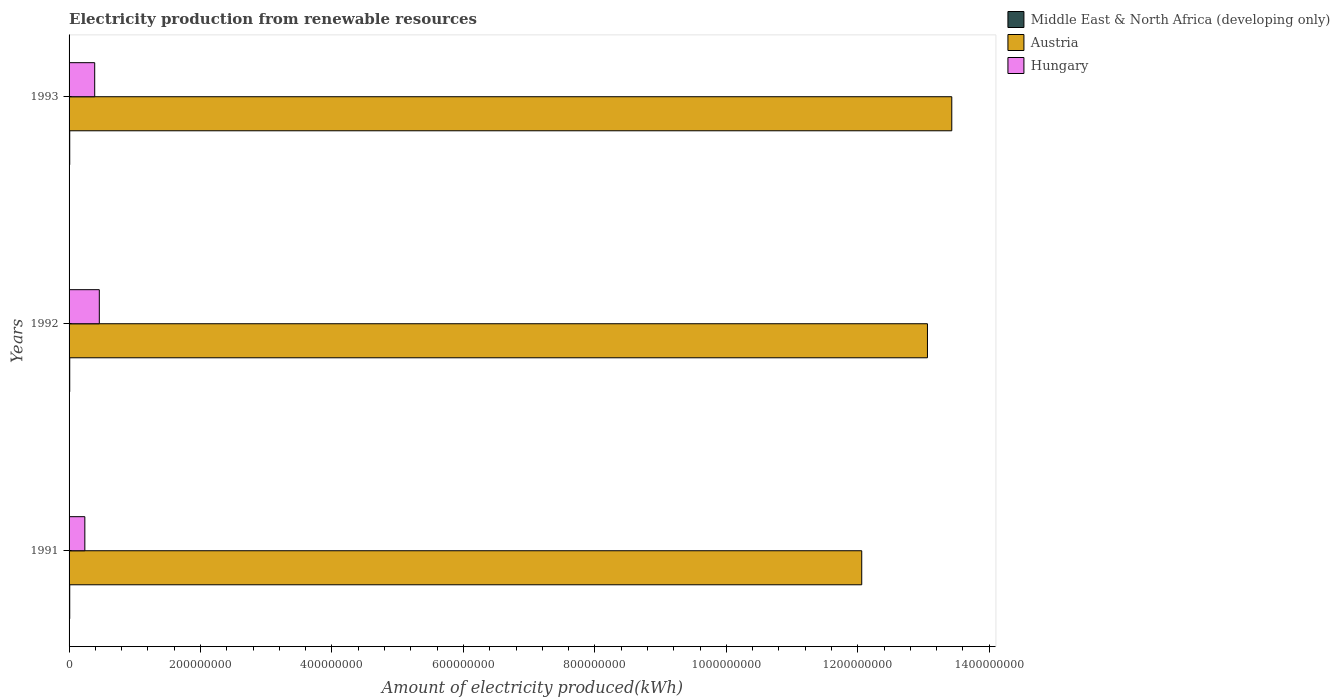How many groups of bars are there?
Provide a short and direct response. 3. How many bars are there on the 2nd tick from the bottom?
Keep it short and to the point. 3. What is the amount of electricity produced in Austria in 1993?
Your answer should be very brief. 1.34e+09. Across all years, what is the maximum amount of electricity produced in Middle East & North Africa (developing only)?
Your answer should be very brief. 1.00e+06. Across all years, what is the minimum amount of electricity produced in Hungary?
Make the answer very short. 2.40e+07. In which year was the amount of electricity produced in Hungary maximum?
Make the answer very short. 1992. What is the total amount of electricity produced in Hungary in the graph?
Offer a terse response. 1.09e+08. What is the difference between the amount of electricity produced in Hungary in 1992 and that in 1993?
Ensure brevity in your answer.  7.00e+06. What is the difference between the amount of electricity produced in Austria in 1993 and the amount of electricity produced in Hungary in 1992?
Provide a succinct answer. 1.30e+09. What is the average amount of electricity produced in Hungary per year?
Your answer should be very brief. 3.63e+07. In the year 1993, what is the difference between the amount of electricity produced in Austria and amount of electricity produced in Middle East & North Africa (developing only)?
Your answer should be compact. 1.34e+09. Is the amount of electricity produced in Middle East & North Africa (developing only) in 1992 less than that in 1993?
Offer a very short reply. No. Is the difference between the amount of electricity produced in Austria in 1991 and 1993 greater than the difference between the amount of electricity produced in Middle East & North Africa (developing only) in 1991 and 1993?
Your answer should be compact. No. What is the difference between the highest and the second highest amount of electricity produced in Austria?
Make the answer very short. 3.70e+07. What is the difference between the highest and the lowest amount of electricity produced in Hungary?
Your answer should be very brief. 2.20e+07. In how many years, is the amount of electricity produced in Middle East & North Africa (developing only) greater than the average amount of electricity produced in Middle East & North Africa (developing only) taken over all years?
Offer a terse response. 0. What does the 3rd bar from the top in 1993 represents?
Offer a terse response. Middle East & North Africa (developing only). What does the 2nd bar from the bottom in 1991 represents?
Make the answer very short. Austria. How many bars are there?
Offer a very short reply. 9. Are all the bars in the graph horizontal?
Your answer should be compact. Yes. How many years are there in the graph?
Keep it short and to the point. 3. Does the graph contain grids?
Keep it short and to the point. No. Where does the legend appear in the graph?
Ensure brevity in your answer.  Top right. How many legend labels are there?
Give a very brief answer. 3. What is the title of the graph?
Keep it short and to the point. Electricity production from renewable resources. Does "Eritrea" appear as one of the legend labels in the graph?
Provide a short and direct response. No. What is the label or title of the X-axis?
Your response must be concise. Amount of electricity produced(kWh). What is the Amount of electricity produced(kWh) in Austria in 1991?
Offer a terse response. 1.21e+09. What is the Amount of electricity produced(kWh) in Hungary in 1991?
Provide a short and direct response. 2.40e+07. What is the Amount of electricity produced(kWh) in Austria in 1992?
Provide a short and direct response. 1.31e+09. What is the Amount of electricity produced(kWh) of Hungary in 1992?
Give a very brief answer. 4.60e+07. What is the Amount of electricity produced(kWh) of Austria in 1993?
Provide a short and direct response. 1.34e+09. What is the Amount of electricity produced(kWh) of Hungary in 1993?
Make the answer very short. 3.90e+07. Across all years, what is the maximum Amount of electricity produced(kWh) of Middle East & North Africa (developing only)?
Your response must be concise. 1.00e+06. Across all years, what is the maximum Amount of electricity produced(kWh) of Austria?
Provide a succinct answer. 1.34e+09. Across all years, what is the maximum Amount of electricity produced(kWh) in Hungary?
Offer a very short reply. 4.60e+07. Across all years, what is the minimum Amount of electricity produced(kWh) of Middle East & North Africa (developing only)?
Offer a terse response. 1.00e+06. Across all years, what is the minimum Amount of electricity produced(kWh) in Austria?
Ensure brevity in your answer.  1.21e+09. Across all years, what is the minimum Amount of electricity produced(kWh) of Hungary?
Your answer should be compact. 2.40e+07. What is the total Amount of electricity produced(kWh) of Austria in the graph?
Offer a terse response. 3.86e+09. What is the total Amount of electricity produced(kWh) in Hungary in the graph?
Make the answer very short. 1.09e+08. What is the difference between the Amount of electricity produced(kWh) of Austria in 1991 and that in 1992?
Give a very brief answer. -1.00e+08. What is the difference between the Amount of electricity produced(kWh) in Hungary in 1991 and that in 1992?
Keep it short and to the point. -2.20e+07. What is the difference between the Amount of electricity produced(kWh) of Austria in 1991 and that in 1993?
Provide a short and direct response. -1.37e+08. What is the difference between the Amount of electricity produced(kWh) in Hungary in 1991 and that in 1993?
Ensure brevity in your answer.  -1.50e+07. What is the difference between the Amount of electricity produced(kWh) in Middle East & North Africa (developing only) in 1992 and that in 1993?
Your answer should be compact. 0. What is the difference between the Amount of electricity produced(kWh) of Austria in 1992 and that in 1993?
Keep it short and to the point. -3.70e+07. What is the difference between the Amount of electricity produced(kWh) of Middle East & North Africa (developing only) in 1991 and the Amount of electricity produced(kWh) of Austria in 1992?
Ensure brevity in your answer.  -1.30e+09. What is the difference between the Amount of electricity produced(kWh) of Middle East & North Africa (developing only) in 1991 and the Amount of electricity produced(kWh) of Hungary in 1992?
Make the answer very short. -4.50e+07. What is the difference between the Amount of electricity produced(kWh) of Austria in 1991 and the Amount of electricity produced(kWh) of Hungary in 1992?
Make the answer very short. 1.16e+09. What is the difference between the Amount of electricity produced(kWh) in Middle East & North Africa (developing only) in 1991 and the Amount of electricity produced(kWh) in Austria in 1993?
Give a very brief answer. -1.34e+09. What is the difference between the Amount of electricity produced(kWh) in Middle East & North Africa (developing only) in 1991 and the Amount of electricity produced(kWh) in Hungary in 1993?
Provide a succinct answer. -3.80e+07. What is the difference between the Amount of electricity produced(kWh) in Austria in 1991 and the Amount of electricity produced(kWh) in Hungary in 1993?
Your answer should be compact. 1.17e+09. What is the difference between the Amount of electricity produced(kWh) of Middle East & North Africa (developing only) in 1992 and the Amount of electricity produced(kWh) of Austria in 1993?
Give a very brief answer. -1.34e+09. What is the difference between the Amount of electricity produced(kWh) in Middle East & North Africa (developing only) in 1992 and the Amount of electricity produced(kWh) in Hungary in 1993?
Your response must be concise. -3.80e+07. What is the difference between the Amount of electricity produced(kWh) of Austria in 1992 and the Amount of electricity produced(kWh) of Hungary in 1993?
Provide a short and direct response. 1.27e+09. What is the average Amount of electricity produced(kWh) of Austria per year?
Offer a very short reply. 1.28e+09. What is the average Amount of electricity produced(kWh) in Hungary per year?
Your answer should be compact. 3.63e+07. In the year 1991, what is the difference between the Amount of electricity produced(kWh) in Middle East & North Africa (developing only) and Amount of electricity produced(kWh) in Austria?
Keep it short and to the point. -1.20e+09. In the year 1991, what is the difference between the Amount of electricity produced(kWh) in Middle East & North Africa (developing only) and Amount of electricity produced(kWh) in Hungary?
Provide a succinct answer. -2.30e+07. In the year 1991, what is the difference between the Amount of electricity produced(kWh) of Austria and Amount of electricity produced(kWh) of Hungary?
Your answer should be compact. 1.18e+09. In the year 1992, what is the difference between the Amount of electricity produced(kWh) of Middle East & North Africa (developing only) and Amount of electricity produced(kWh) of Austria?
Make the answer very short. -1.30e+09. In the year 1992, what is the difference between the Amount of electricity produced(kWh) of Middle East & North Africa (developing only) and Amount of electricity produced(kWh) of Hungary?
Offer a very short reply. -4.50e+07. In the year 1992, what is the difference between the Amount of electricity produced(kWh) of Austria and Amount of electricity produced(kWh) of Hungary?
Your answer should be compact. 1.26e+09. In the year 1993, what is the difference between the Amount of electricity produced(kWh) in Middle East & North Africa (developing only) and Amount of electricity produced(kWh) in Austria?
Offer a terse response. -1.34e+09. In the year 1993, what is the difference between the Amount of electricity produced(kWh) in Middle East & North Africa (developing only) and Amount of electricity produced(kWh) in Hungary?
Your answer should be compact. -3.80e+07. In the year 1993, what is the difference between the Amount of electricity produced(kWh) of Austria and Amount of electricity produced(kWh) of Hungary?
Give a very brief answer. 1.30e+09. What is the ratio of the Amount of electricity produced(kWh) of Middle East & North Africa (developing only) in 1991 to that in 1992?
Provide a short and direct response. 1. What is the ratio of the Amount of electricity produced(kWh) of Austria in 1991 to that in 1992?
Keep it short and to the point. 0.92. What is the ratio of the Amount of electricity produced(kWh) of Hungary in 1991 to that in 1992?
Offer a terse response. 0.52. What is the ratio of the Amount of electricity produced(kWh) of Austria in 1991 to that in 1993?
Ensure brevity in your answer.  0.9. What is the ratio of the Amount of electricity produced(kWh) of Hungary in 1991 to that in 1993?
Keep it short and to the point. 0.62. What is the ratio of the Amount of electricity produced(kWh) in Austria in 1992 to that in 1993?
Offer a terse response. 0.97. What is the ratio of the Amount of electricity produced(kWh) in Hungary in 1992 to that in 1993?
Your response must be concise. 1.18. What is the difference between the highest and the second highest Amount of electricity produced(kWh) of Middle East & North Africa (developing only)?
Keep it short and to the point. 0. What is the difference between the highest and the second highest Amount of electricity produced(kWh) in Austria?
Your answer should be very brief. 3.70e+07. What is the difference between the highest and the lowest Amount of electricity produced(kWh) of Middle East & North Africa (developing only)?
Give a very brief answer. 0. What is the difference between the highest and the lowest Amount of electricity produced(kWh) in Austria?
Ensure brevity in your answer.  1.37e+08. What is the difference between the highest and the lowest Amount of electricity produced(kWh) in Hungary?
Provide a short and direct response. 2.20e+07. 